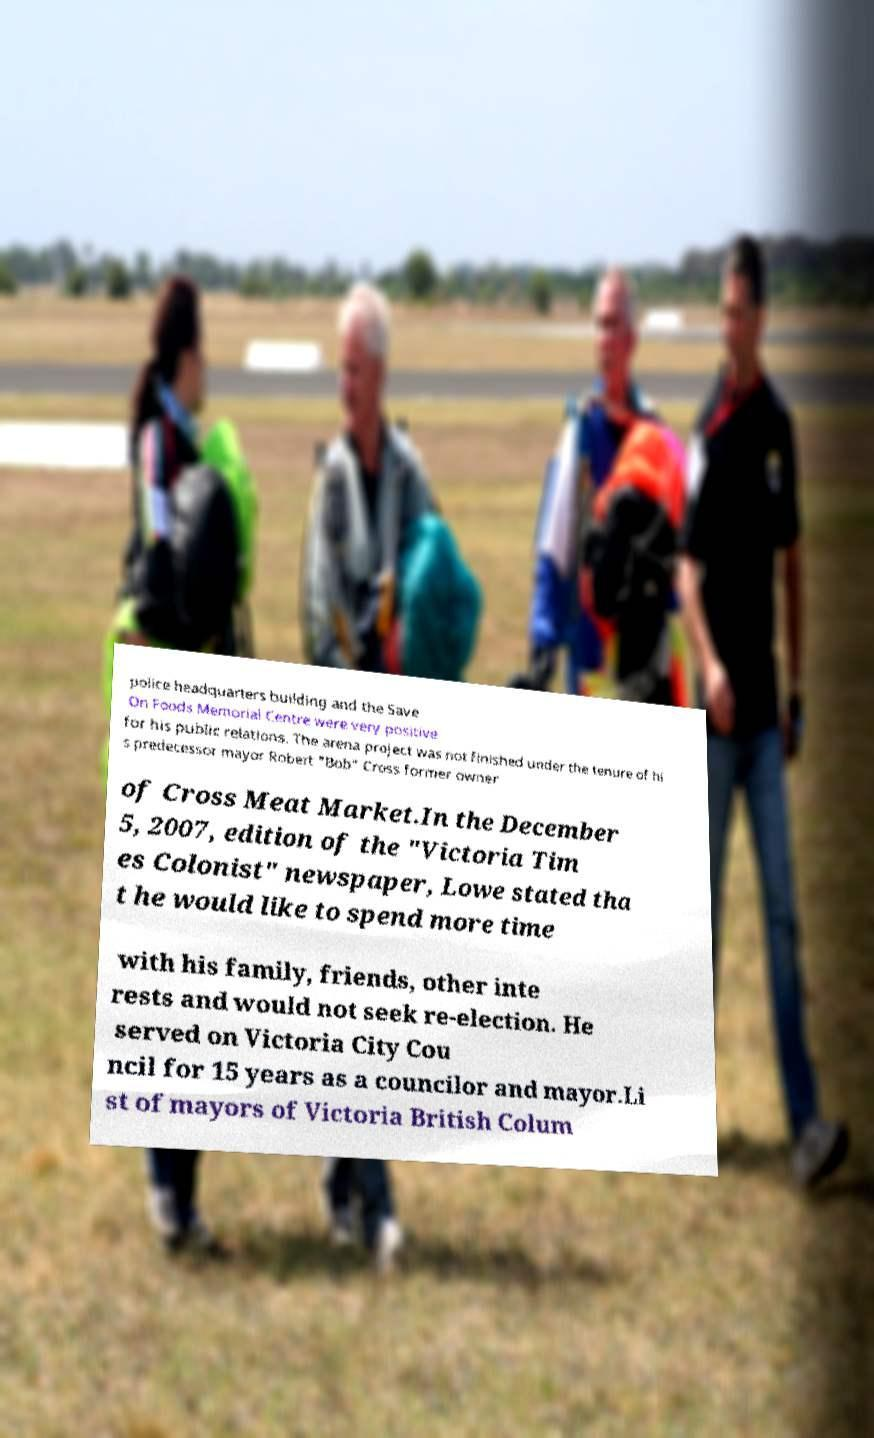I need the written content from this picture converted into text. Can you do that? police headquarters building and the Save On Foods Memorial Centre were very positive for his public relations. The arena project was not finished under the tenure of hi s predecessor mayor Robert "Bob" Cross former owner of Cross Meat Market.In the December 5, 2007, edition of the "Victoria Tim es Colonist" newspaper, Lowe stated tha t he would like to spend more time with his family, friends, other inte rests and would not seek re-election. He served on Victoria City Cou ncil for 15 years as a councilor and mayor.Li st of mayors of Victoria British Colum 